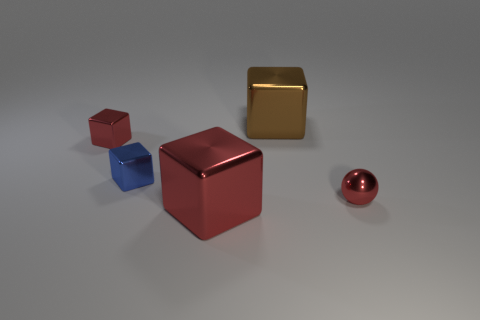What color is the large block that is in front of the tiny red shiny ball?
Your response must be concise. Red. There is a large brown thing; what shape is it?
Your answer should be compact. Cube. Is there a large metal block that is left of the large thing behind the red object right of the brown metallic cube?
Offer a terse response. Yes. The large object that is behind the red block that is to the right of the tiny red object to the left of the blue metallic object is what color?
Provide a short and direct response. Brown. There is a shiny thing that is to the right of the big shiny block that is behind the small ball; what is its size?
Your response must be concise. Small. There is a sphere that is the same material as the small blue object; what is its size?
Provide a succinct answer. Small. How many small red objects are the same shape as the large red metal object?
Give a very brief answer. 1. Is the shape of the big brown shiny thing the same as the small red metallic object right of the blue cube?
Ensure brevity in your answer.  No. There is a large object that is the same color as the tiny metallic ball; what shape is it?
Your answer should be compact. Cube. Are there any blue blocks made of the same material as the tiny red block?
Provide a short and direct response. Yes. 